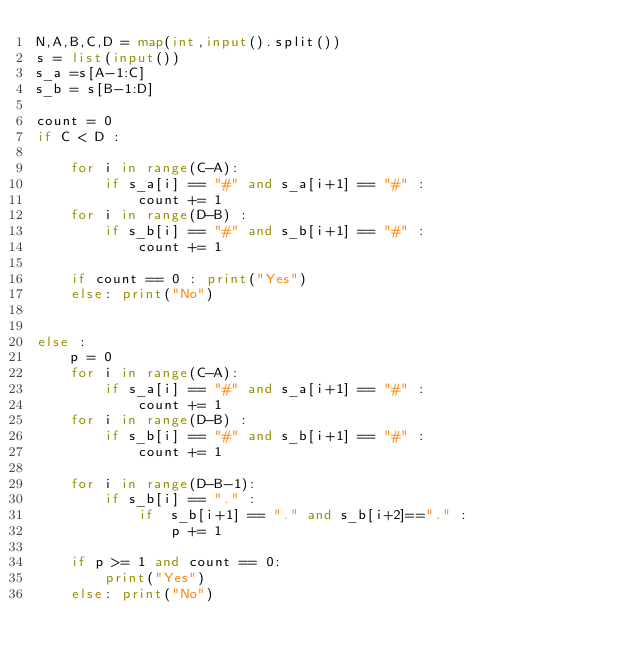Convert code to text. <code><loc_0><loc_0><loc_500><loc_500><_Python_>N,A,B,C,D = map(int,input().split())
s = list(input())
s_a =s[A-1:C]
s_b = s[B-1:D]

count = 0
if C < D :

    for i in range(C-A):
        if s_a[i] == "#" and s_a[i+1] == "#" :
            count += 1
    for i in range(D-B) :
        if s_b[i] == "#" and s_b[i+1] == "#" : 
            count += 1

    if count == 0 : print("Yes")
    else: print("No")


else :
    p = 0
    for i in range(C-A):
        if s_a[i] == "#" and s_a[i+1] == "#" :
            count += 1
    for i in range(D-B) :
        if s_b[i] == "#" and s_b[i+1] == "#" : 
            count += 1
    
    for i in range(D-B-1):
        if s_b[i] == "." :
            if  s_b[i+1] == "." and s_b[i+2]=="." :
                p += 1
    
    if p >= 1 and count == 0:
        print("Yes")
    else: print("No")</code> 